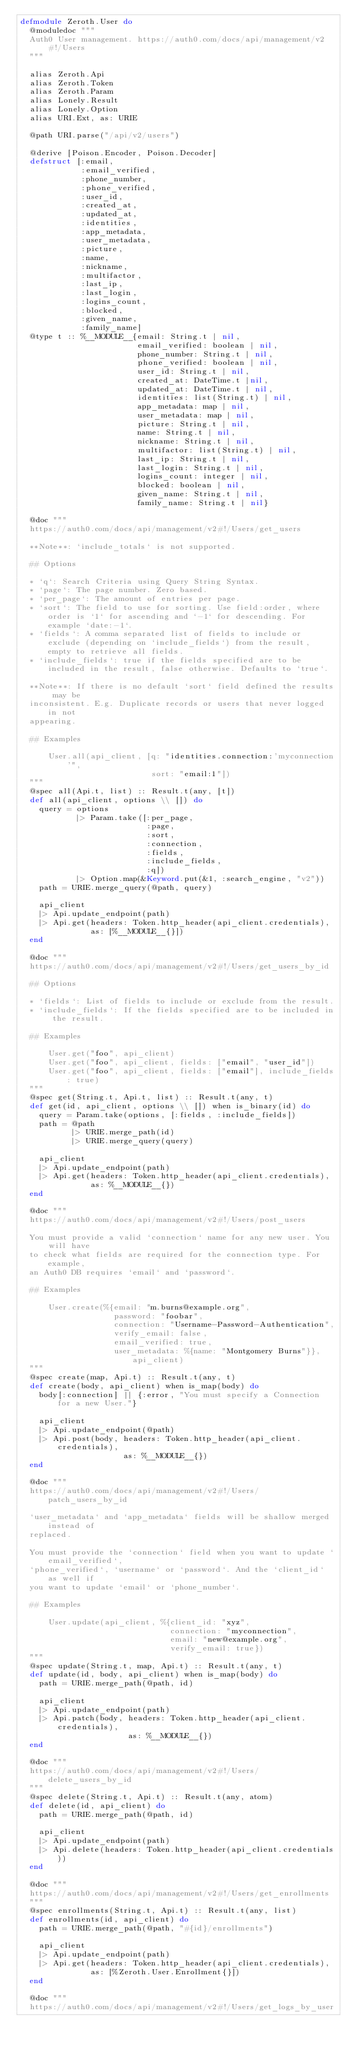<code> <loc_0><loc_0><loc_500><loc_500><_Elixir_>defmodule Zeroth.User do
  @moduledoc """
  Auth0 User management. https://auth0.com/docs/api/management/v2#!/Users
  """

  alias Zeroth.Api
  alias Zeroth.Token
  alias Zeroth.Param
  alias Lonely.Result
  alias Lonely.Option
  alias URI.Ext, as: URIE

  @path URI.parse("/api/v2/users")

  @derive [Poison.Encoder, Poison.Decoder]
  defstruct [:email,
             :email_verified,
             :phone_number,
             :phone_verified,
             :user_id,
             :created_at,
             :updated_at,
             :identities,
             :app_metadata,
             :user_metadata,
             :picture,
             :name,
             :nickname,
             :multifactor,
             :last_ip,
             :last_login,
             :logins_count,
             :blocked,
             :given_name,
             :family_name]
  @type t :: %__MODULE__{email: String.t | nil,
                         email_verified: boolean | nil,
                         phone_number: String.t | nil,
                         phone_verified: boolean | nil,
                         user_id: String.t | nil,
                         created_at: DateTime.t |nil,
                         updated_at: DateTime.t | nil,
                         identities: list(String.t) | nil,
                         app_metadata: map | nil,
                         user_metadata: map | nil,
                         picture: String.t | nil,
                         name: String.t | nil,
                         nickname: String.t | nil,
                         multifactor: list(String.t) | nil,
                         last_ip: String.t | nil,
                         last_login: String.t | nil,
                         logins_count: integer | nil,
                         blocked: boolean | nil,
                         given_name: String.t | nil,
                         family_name: String.t | nil}

  @doc """
  https://auth0.com/docs/api/management/v2#!/Users/get_users

  **Note**: `include_totals` is not supported.

  ## Options

  * `q`: Search Criteria using Query String Syntax.
  * `page`: The page number. Zero based.
  * `per_page`: The amount of entries per page.
  * `sort`: The field to use for sorting. Use field:order, where order is `1` for ascending and `-1` for descending. For example `date:-1`.
  * `fields`: A comma separated list of fields to include or exclude (depending on `include_fields`) from the result, empty to retrieve all fields.
  * `include_fields`: true if the fields specified are to be included in the result, false otherwise. Defaults to `true`.

  **Note**: If there is no default `sort` field defined the results may be
  inconsistent. E.g. Duplicate records or users that never logged in not
  appearing.

  ## Examples

      User.all(api_client, [q: "identities.connection:'myconnection'",
                            sort: "email:1"])
  """
  @spec all(Api.t, list) :: Result.t(any, [t])
  def all(api_client, options \\ []) do
    query = options
            |> Param.take([:per_page,
                           :page,
                           :sort,
                           :connection,
                           :fields,
                           :include_fields,
                           :q])
            |> Option.map(&Keyword.put(&1, :search_engine, "v2"))
    path = URIE.merge_query(@path, query)

    api_client
    |> Api.update_endpoint(path)
    |> Api.get(headers: Token.http_header(api_client.credentials),
               as: [%__MODULE__{}])
  end

  @doc """
  https://auth0.com/docs/api/management/v2#!/Users/get_users_by_id

  ## Options

  * `fields`: List of fields to include or exclude from the result.
  * `include_fields`: If the fields specified are to be included in the result.

  ## Examples

      User.get("foo", api_client)
      User.get("foo", api_client, fields: ["email", "user_id"])
      User.get("foo", api_client, fields: ["email"], include_fields: true)
  """
  @spec get(String.t, Api.t, list) :: Result.t(any, t)
  def get(id, api_client, options \\ []) when is_binary(id) do
    query = Param.take(options, [:fields, :include_fields])
    path = @path
           |> URIE.merge_path(id)
           |> URIE.merge_query(query)

    api_client
    |> Api.update_endpoint(path)
    |> Api.get(headers: Token.http_header(api_client.credentials),
               as: %__MODULE__{})
  end

  @doc """
  https://auth0.com/docs/api/management/v2#!/Users/post_users

  You must provide a valid `connection` name for any new user. You will have
  to check what fields are required for the connection type. For example,
  an Auth0 DB requires `email` and `password`.

  ## Examples

      User.create(%{email: "m.burns@example.org",
                    password: "foobar",
                    connection: "Username-Password-Authentication",
                    verify_email: false,
                    email_verified: true,
                    user_metadata: %{name: "Montgomery Burns"}}, api_client)
  """
  @spec create(map, Api.t) :: Result.t(any, t)
  def create(body, api_client) when is_map(body) do
    body[:connection] || {:error, "You must specify a Connection for a new User."}

    api_client
    |> Api.update_endpoint(@path)
    |> Api.post(body, headers: Token.http_header(api_client.credentials),
                      as: %__MODULE__{})
  end

  @doc """
  https://auth0.com/docs/api/management/v2#!/Users/patch_users_by_id

  `user_metadata` and `app_metadata` fields will be shallow merged instead of
  replaced.

  You must provide the `connection` field when you want to update `email_verified`,
  `phone_verified`, `username` or `password`. And the `client_id` as well if
  you want to update `email` or `phone_number`.

  ## Examples

      User.update(api_client, %{client_id: "xyz",
                                connection: "myconnection",
                                email: "new@example.org",
                                verify_email: true})
  """
  @spec update(String.t, map, Api.t) :: Result.t(any, t)
  def update(id, body, api_client) when is_map(body) do
    path = URIE.merge_path(@path, id)

    api_client
    |> Api.update_endpoint(path)
    |> Api.patch(body, headers: Token.http_header(api_client.credentials),
                       as: %__MODULE__{})
  end

  @doc """
  https://auth0.com/docs/api/management/v2#!/Users/delete_users_by_id
  """
  @spec delete(String.t, Api.t) :: Result.t(any, atom)
  def delete(id, api_client) do
    path = URIE.merge_path(@path, id)

    api_client
    |> Api.update_endpoint(path)
    |> Api.delete(headers: Token.http_header(api_client.credentials))
  end

  @doc """
  https://auth0.com/docs/api/management/v2#!/Users/get_enrollments
  """
  @spec enrollments(String.t, Api.t) :: Result.t(any, list)
  def enrollments(id, api_client) do
    path = URIE.merge_path(@path, "#{id}/enrollments")

    api_client
    |> Api.update_endpoint(path)
    |> Api.get(headers: Token.http_header(api_client.credentials),
               as: [%Zeroth.User.Enrollment{}])
  end

  @doc """
  https://auth0.com/docs/api/management/v2#!/Users/get_logs_by_user
</code> 